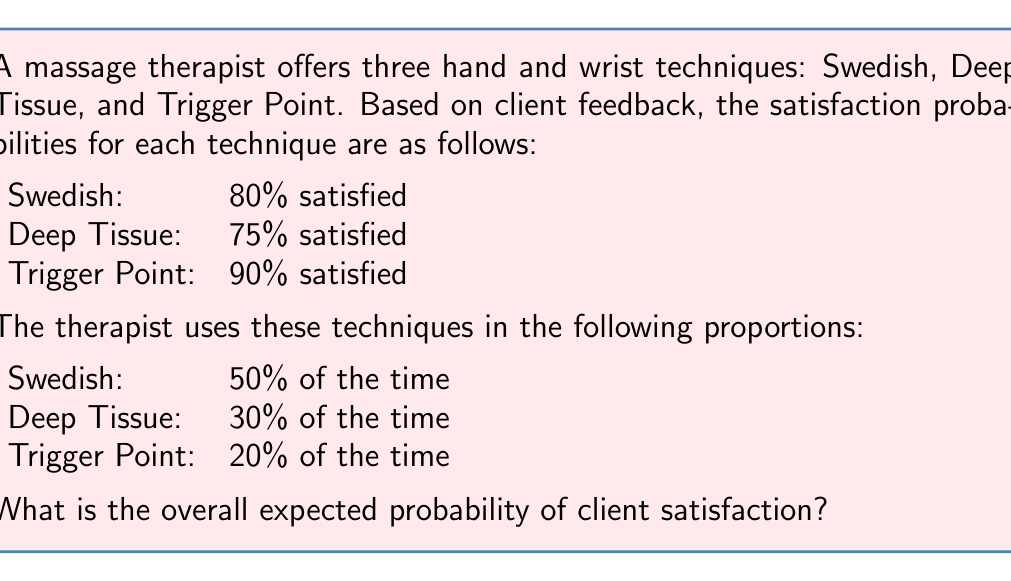Provide a solution to this math problem. To solve this problem, we need to calculate the weighted average of the satisfaction probabilities based on the frequency of each technique's use. This is an application of the law of total probability.

Let's break it down step-by-step:

1) First, let's define our events:
   $S$ = Swedish technique
   $D$ = Deep Tissue technique
   $T$ = Trigger Point technique
   $C$ = Client is satisfied

2) We're given the following probabilities:
   $P(C|S) = 0.80$
   $P(C|D) = 0.75$
   $P(C|T) = 0.90$
   $P(S) = 0.50$
   $P(D) = 0.30$
   $P(T) = 0.20$

3) We can use the law of total probability:
   $P(C) = P(C|S)P(S) + P(C|D)P(D) + P(C|T)P(T)$

4) Now, let's substitute the values:
   $P(C) = (0.80)(0.50) + (0.75)(0.30) + (0.90)(0.20)$

5) Calculate each term:
   $P(C) = 0.40 + 0.225 + 0.18$

6) Sum up the terms:
   $P(C) = 0.805$

Therefore, the overall expected probability of client satisfaction is 0.805 or 80.5%.
Answer: 0.805 or 80.5% 